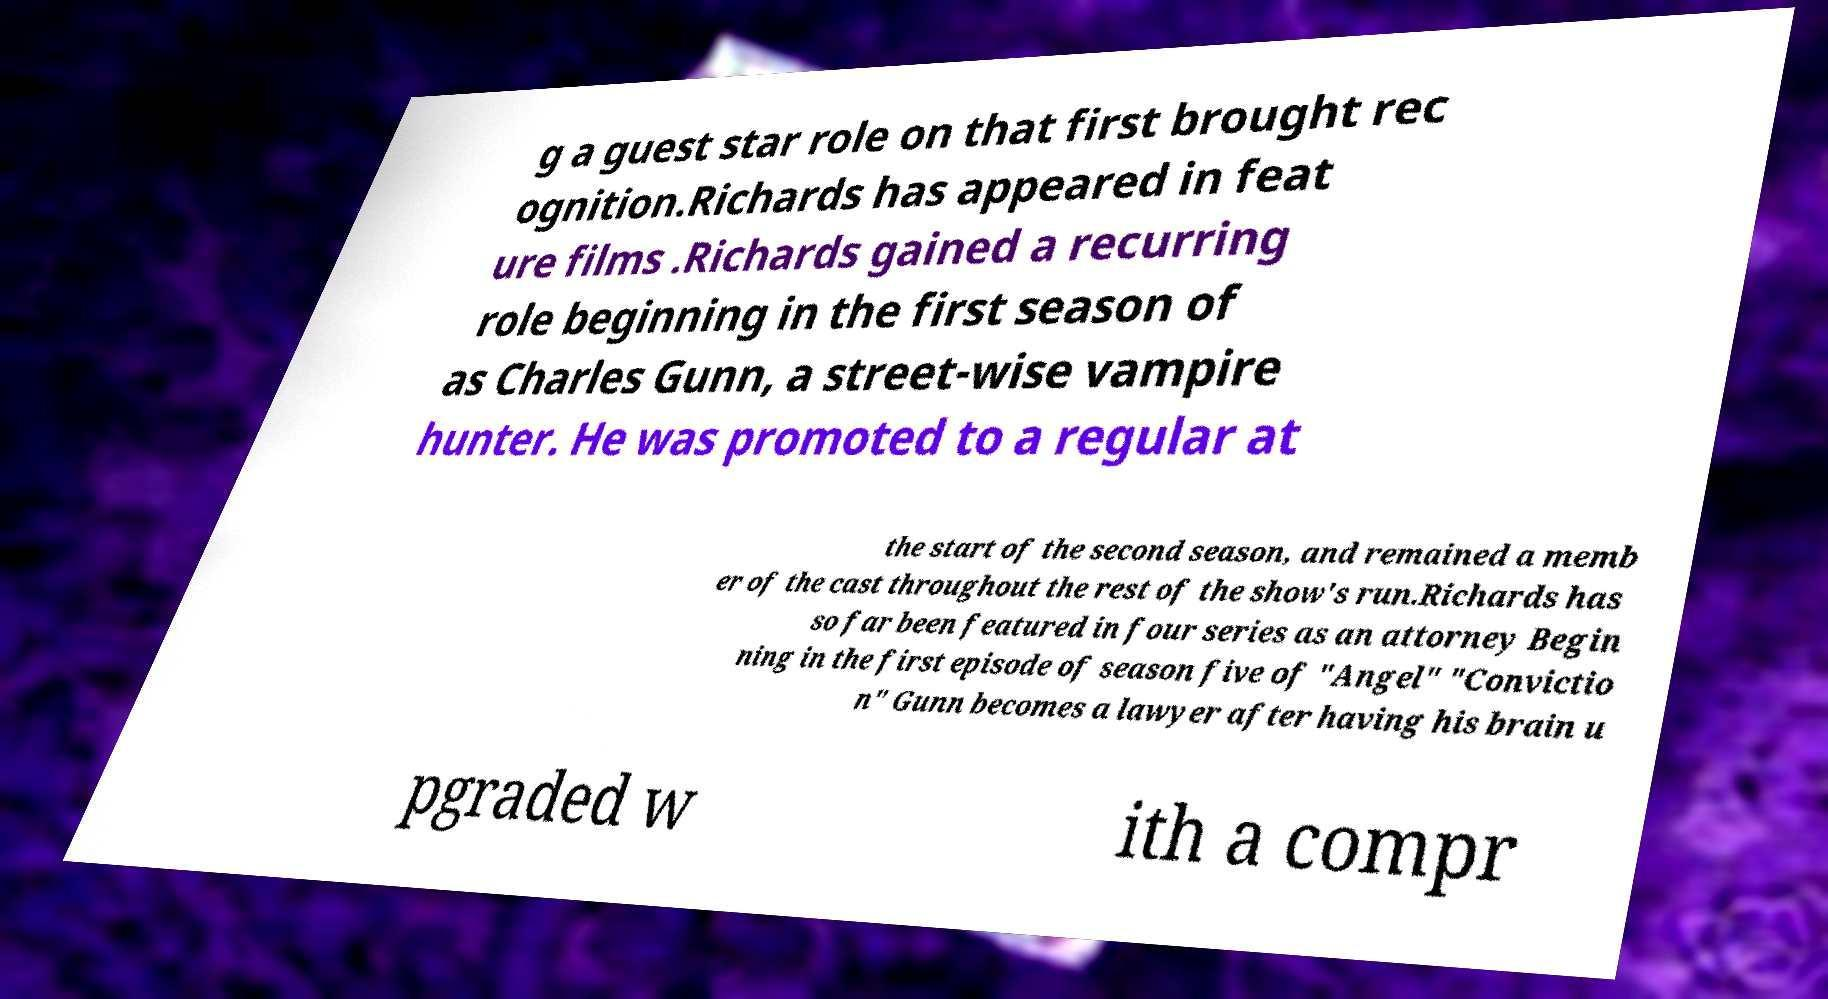For documentation purposes, I need the text within this image transcribed. Could you provide that? g a guest star role on that first brought rec ognition.Richards has appeared in feat ure films .Richards gained a recurring role beginning in the first season of as Charles Gunn, a street-wise vampire hunter. He was promoted to a regular at the start of the second season, and remained a memb er of the cast throughout the rest of the show's run.Richards has so far been featured in four series as an attorney Begin ning in the first episode of season five of "Angel" "Convictio n" Gunn becomes a lawyer after having his brain u pgraded w ith a compr 